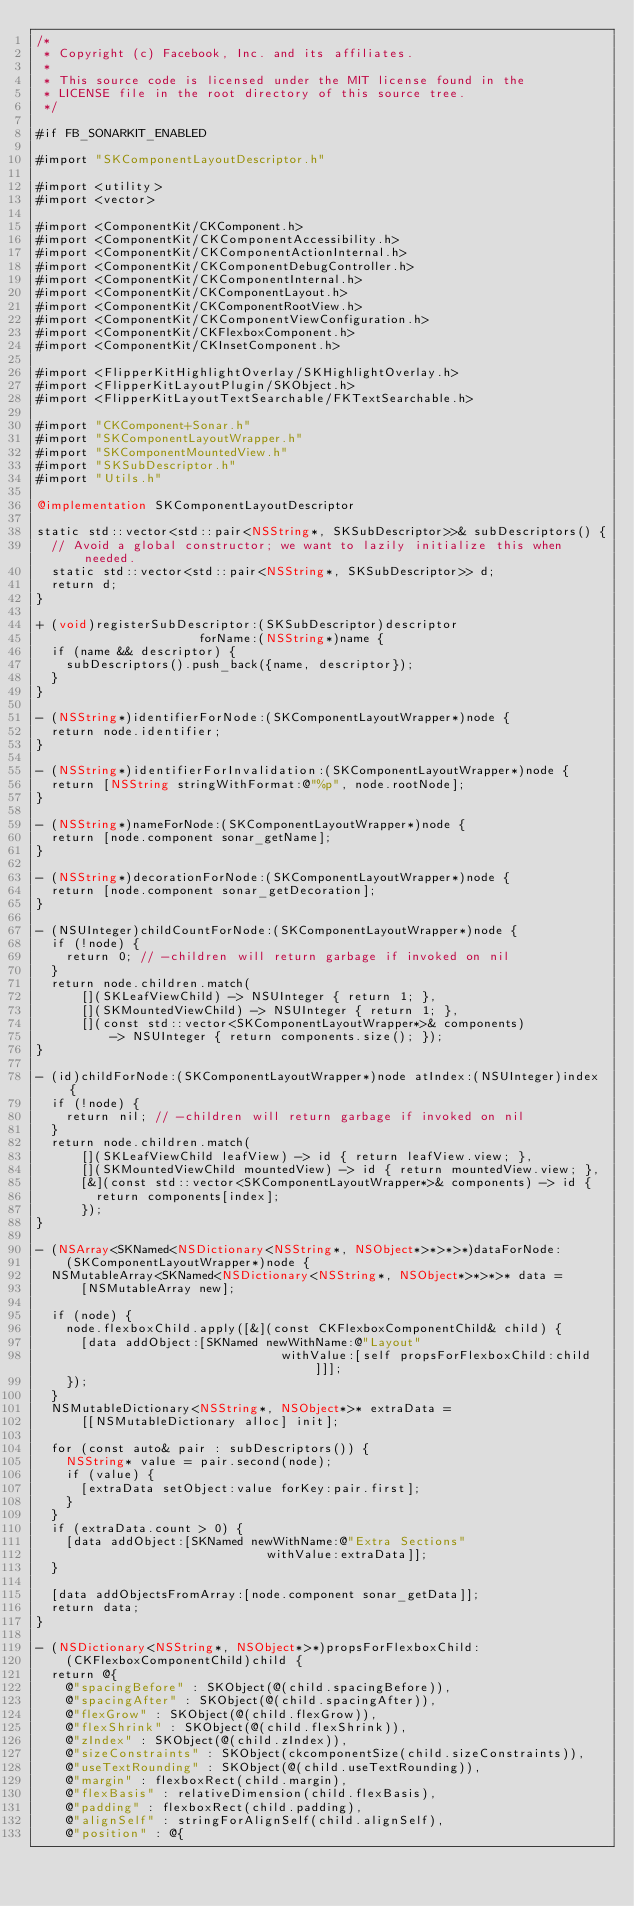<code> <loc_0><loc_0><loc_500><loc_500><_ObjectiveC_>/*
 * Copyright (c) Facebook, Inc. and its affiliates.
 *
 * This source code is licensed under the MIT license found in the
 * LICENSE file in the root directory of this source tree.
 */

#if FB_SONARKIT_ENABLED

#import "SKComponentLayoutDescriptor.h"

#import <utility>
#import <vector>

#import <ComponentKit/CKComponent.h>
#import <ComponentKit/CKComponentAccessibility.h>
#import <ComponentKit/CKComponentActionInternal.h>
#import <ComponentKit/CKComponentDebugController.h>
#import <ComponentKit/CKComponentInternal.h>
#import <ComponentKit/CKComponentLayout.h>
#import <ComponentKit/CKComponentRootView.h>
#import <ComponentKit/CKComponentViewConfiguration.h>
#import <ComponentKit/CKFlexboxComponent.h>
#import <ComponentKit/CKInsetComponent.h>

#import <FlipperKitHighlightOverlay/SKHighlightOverlay.h>
#import <FlipperKitLayoutPlugin/SKObject.h>
#import <FlipperKitLayoutTextSearchable/FKTextSearchable.h>

#import "CKComponent+Sonar.h"
#import "SKComponentLayoutWrapper.h"
#import "SKComponentMountedView.h"
#import "SKSubDescriptor.h"
#import "Utils.h"

@implementation SKComponentLayoutDescriptor

static std::vector<std::pair<NSString*, SKSubDescriptor>>& subDescriptors() {
  // Avoid a global constructor; we want to lazily initialize this when needed.
  static std::vector<std::pair<NSString*, SKSubDescriptor>> d;
  return d;
}

+ (void)registerSubDescriptor:(SKSubDescriptor)descriptor
                      forName:(NSString*)name {
  if (name && descriptor) {
    subDescriptors().push_back({name, descriptor});
  }
}

- (NSString*)identifierForNode:(SKComponentLayoutWrapper*)node {
  return node.identifier;
}

- (NSString*)identifierForInvalidation:(SKComponentLayoutWrapper*)node {
  return [NSString stringWithFormat:@"%p", node.rootNode];
}

- (NSString*)nameForNode:(SKComponentLayoutWrapper*)node {
  return [node.component sonar_getName];
}

- (NSString*)decorationForNode:(SKComponentLayoutWrapper*)node {
  return [node.component sonar_getDecoration];
}

- (NSUInteger)childCountForNode:(SKComponentLayoutWrapper*)node {
  if (!node) {
    return 0; // -children will return garbage if invoked on nil
  }
  return node.children.match(
      [](SKLeafViewChild) -> NSUInteger { return 1; },
      [](SKMountedViewChild) -> NSUInteger { return 1; },
      [](const std::vector<SKComponentLayoutWrapper*>& components)
          -> NSUInteger { return components.size(); });
}

- (id)childForNode:(SKComponentLayoutWrapper*)node atIndex:(NSUInteger)index {
  if (!node) {
    return nil; // -children will return garbage if invoked on nil
  }
  return node.children.match(
      [](SKLeafViewChild leafView) -> id { return leafView.view; },
      [](SKMountedViewChild mountedView) -> id { return mountedView.view; },
      [&](const std::vector<SKComponentLayoutWrapper*>& components) -> id {
        return components[index];
      });
}

- (NSArray<SKNamed<NSDictionary<NSString*, NSObject*>*>*>*)dataForNode:
    (SKComponentLayoutWrapper*)node {
  NSMutableArray<SKNamed<NSDictionary<NSString*, NSObject*>*>*>* data =
      [NSMutableArray new];

  if (node) {
    node.flexboxChild.apply([&](const CKFlexboxComponentChild& child) {
      [data addObject:[SKNamed newWithName:@"Layout"
                                 withValue:[self propsForFlexboxChild:child]]];
    });
  }
  NSMutableDictionary<NSString*, NSObject*>* extraData =
      [[NSMutableDictionary alloc] init];

  for (const auto& pair : subDescriptors()) {
    NSString* value = pair.second(node);
    if (value) {
      [extraData setObject:value forKey:pair.first];
    }
  }
  if (extraData.count > 0) {
    [data addObject:[SKNamed newWithName:@"Extra Sections"
                               withValue:extraData]];
  }

  [data addObjectsFromArray:[node.component sonar_getData]];
  return data;
}

- (NSDictionary<NSString*, NSObject*>*)propsForFlexboxChild:
    (CKFlexboxComponentChild)child {
  return @{
    @"spacingBefore" : SKObject(@(child.spacingBefore)),
    @"spacingAfter" : SKObject(@(child.spacingAfter)),
    @"flexGrow" : SKObject(@(child.flexGrow)),
    @"flexShrink" : SKObject(@(child.flexShrink)),
    @"zIndex" : SKObject(@(child.zIndex)),
    @"sizeConstraints" : SKObject(ckcomponentSize(child.sizeConstraints)),
    @"useTextRounding" : SKObject(@(child.useTextRounding)),
    @"margin" : flexboxRect(child.margin),
    @"flexBasis" : relativeDimension(child.flexBasis),
    @"padding" : flexboxRect(child.padding),
    @"alignSelf" : stringForAlignSelf(child.alignSelf),
    @"position" : @{</code> 